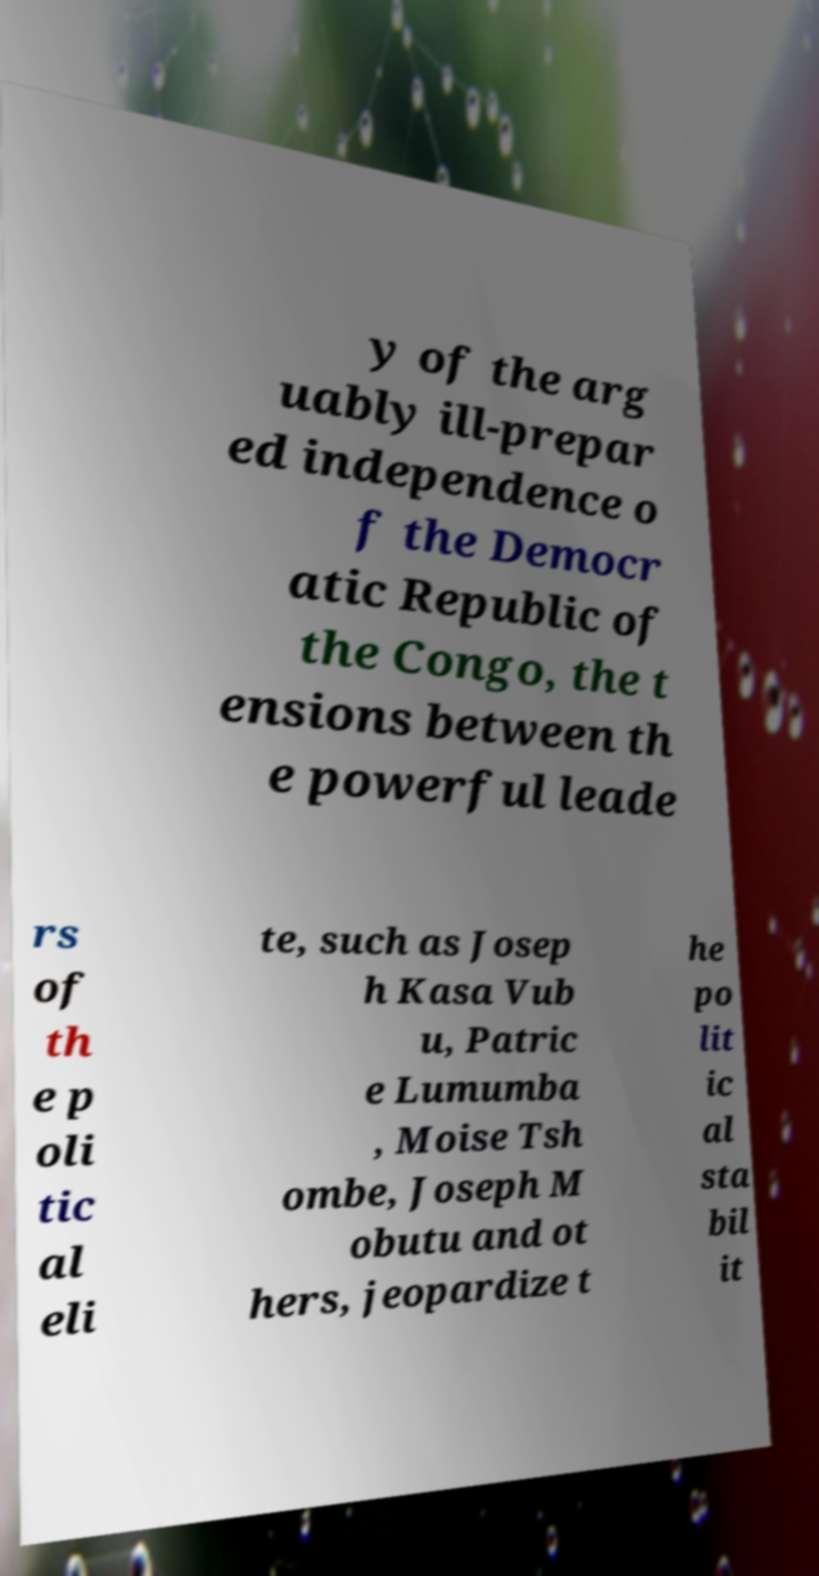Could you extract and type out the text from this image? y of the arg uably ill-prepar ed independence o f the Democr atic Republic of the Congo, the t ensions between th e powerful leade rs of th e p oli tic al eli te, such as Josep h Kasa Vub u, Patric e Lumumba , Moise Tsh ombe, Joseph M obutu and ot hers, jeopardize t he po lit ic al sta bil it 